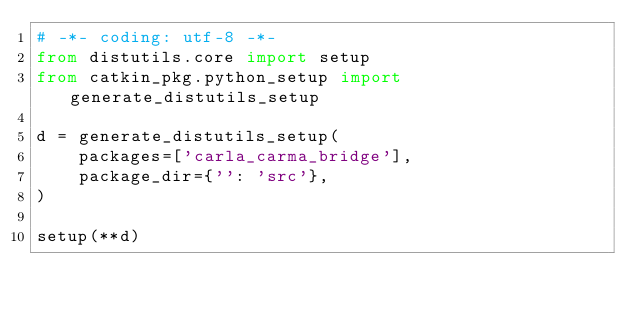<code> <loc_0><loc_0><loc_500><loc_500><_Python_># -*- coding: utf-8 -*-
from distutils.core import setup
from catkin_pkg.python_setup import generate_distutils_setup

d = generate_distutils_setup(
    packages=['carla_carma_bridge'],
    package_dir={'': 'src'},
)

setup(**d)
</code> 